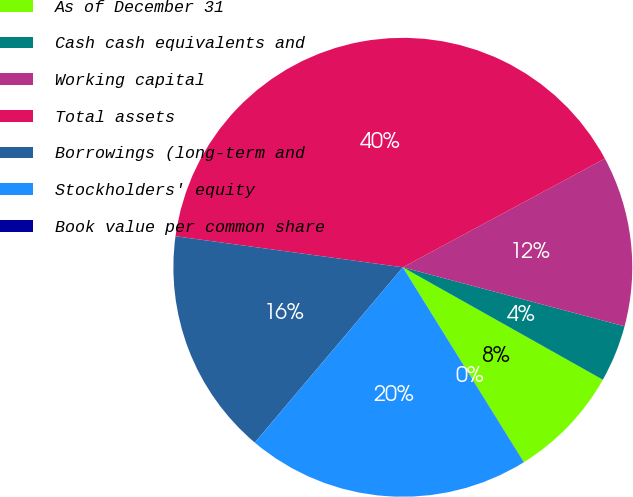Convert chart to OTSL. <chart><loc_0><loc_0><loc_500><loc_500><pie_chart><fcel>As of December 31<fcel>Cash cash equivalents and<fcel>Working capital<fcel>Total assets<fcel>Borrowings (long-term and<fcel>Stockholders' equity<fcel>Book value per common share<nl><fcel>8.01%<fcel>4.01%<fcel>12.0%<fcel>39.98%<fcel>16.0%<fcel>19.99%<fcel>0.01%<nl></chart> 